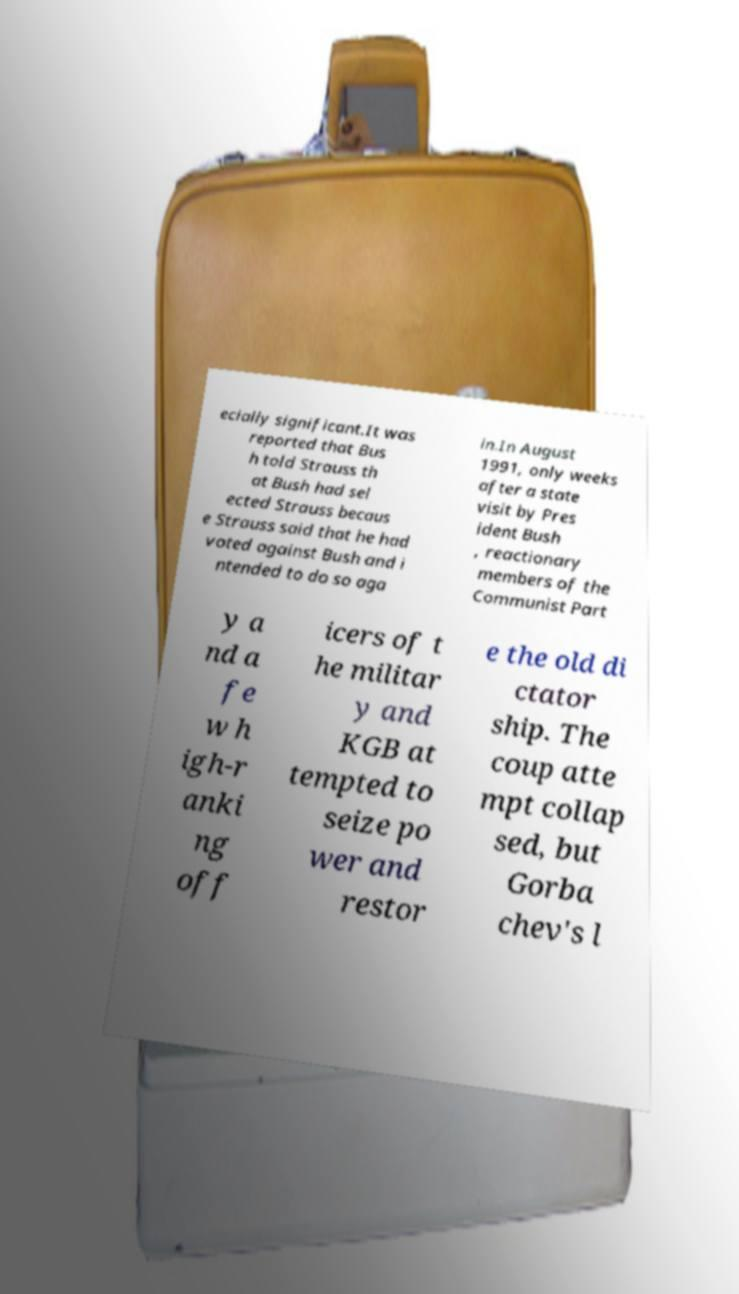Could you assist in decoding the text presented in this image and type it out clearly? ecially significant.It was reported that Bus h told Strauss th at Bush had sel ected Strauss becaus e Strauss said that he had voted against Bush and i ntended to do so aga in.In August 1991, only weeks after a state visit by Pres ident Bush , reactionary members of the Communist Part y a nd a fe w h igh-r anki ng off icers of t he militar y and KGB at tempted to seize po wer and restor e the old di ctator ship. The coup atte mpt collap sed, but Gorba chev's l 